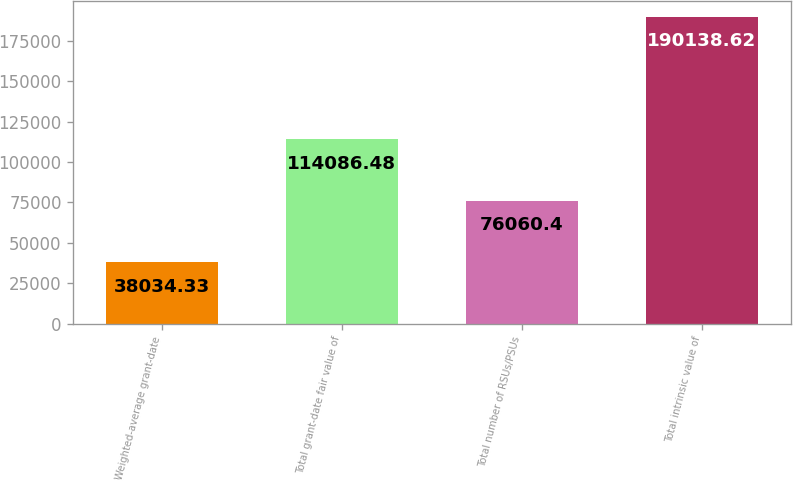<chart> <loc_0><loc_0><loc_500><loc_500><bar_chart><fcel>Weighted-average grant-date<fcel>Total grant-date fair value of<fcel>Total number of RSUs/PSUs<fcel>Total intrinsic value of<nl><fcel>38034.3<fcel>114086<fcel>76060.4<fcel>190139<nl></chart> 